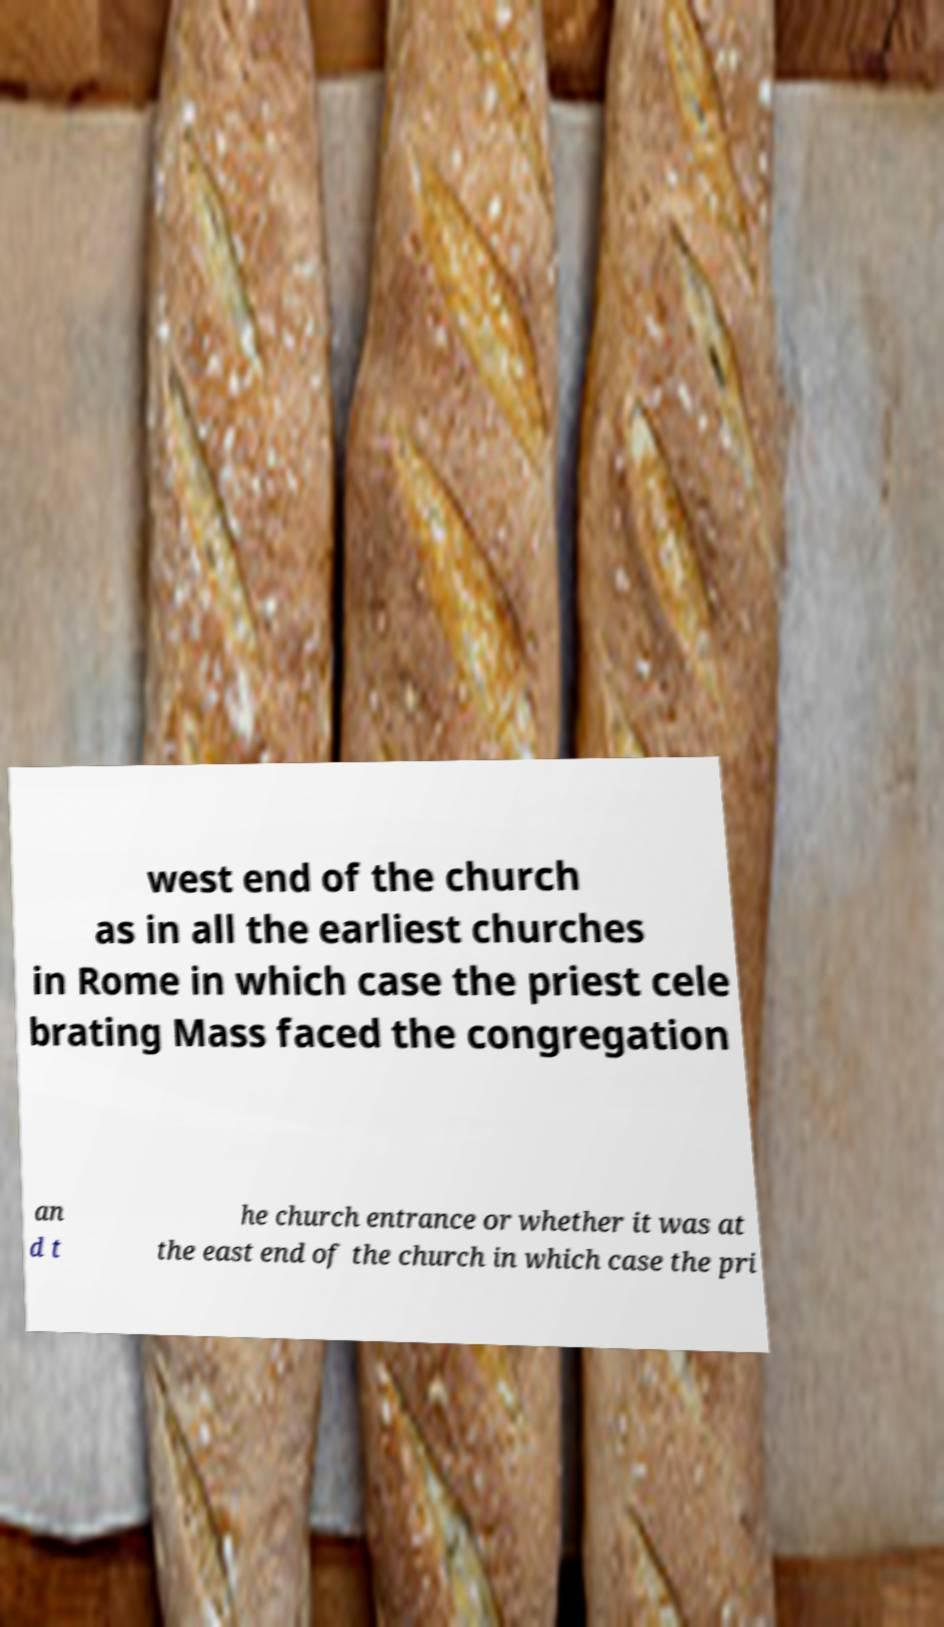Can you accurately transcribe the text from the provided image for me? west end of the church as in all the earliest churches in Rome in which case the priest cele brating Mass faced the congregation an d t he church entrance or whether it was at the east end of the church in which case the pri 